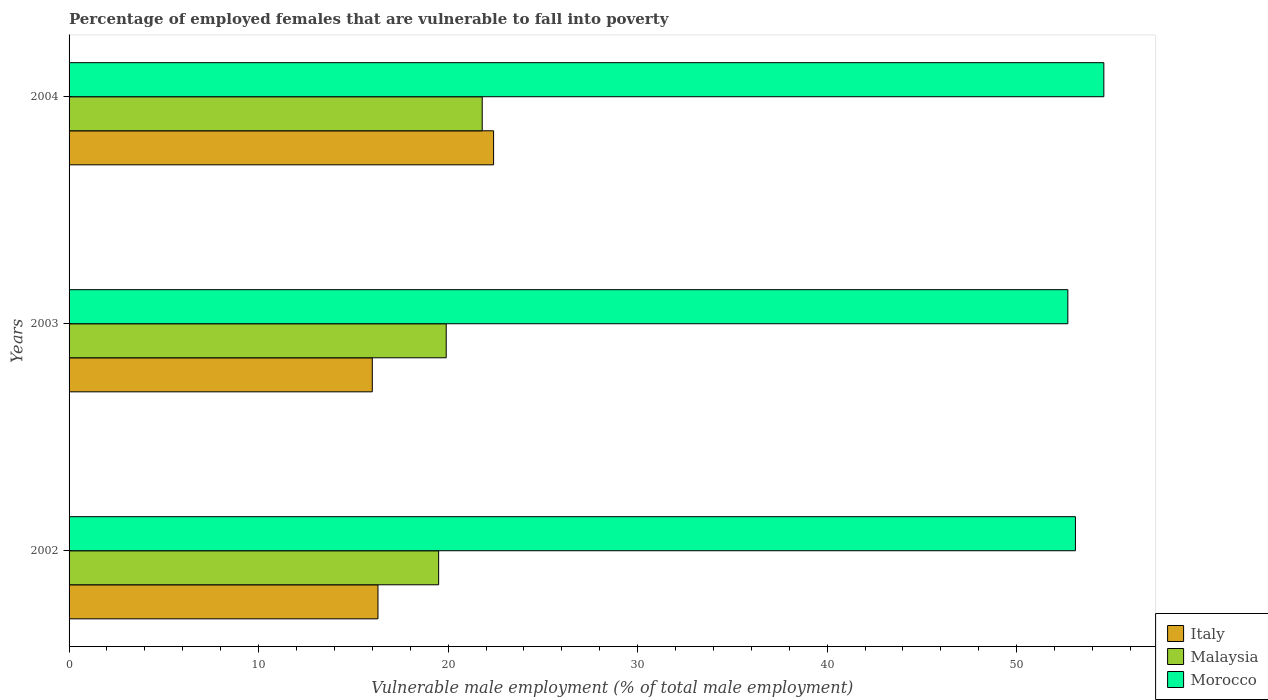How many different coloured bars are there?
Your answer should be compact. 3. How many groups of bars are there?
Give a very brief answer. 3. Are the number of bars on each tick of the Y-axis equal?
Make the answer very short. Yes. How many bars are there on the 1st tick from the bottom?
Your answer should be compact. 3. What is the label of the 1st group of bars from the top?
Your response must be concise. 2004. In how many cases, is the number of bars for a given year not equal to the number of legend labels?
Provide a short and direct response. 0. What is the percentage of employed females who are vulnerable to fall into poverty in Malaysia in 2002?
Keep it short and to the point. 19.5. Across all years, what is the maximum percentage of employed females who are vulnerable to fall into poverty in Morocco?
Your response must be concise. 54.6. Across all years, what is the minimum percentage of employed females who are vulnerable to fall into poverty in Morocco?
Provide a succinct answer. 52.7. In which year was the percentage of employed females who are vulnerable to fall into poverty in Malaysia maximum?
Provide a short and direct response. 2004. What is the total percentage of employed females who are vulnerable to fall into poverty in Italy in the graph?
Ensure brevity in your answer.  54.7. What is the difference between the percentage of employed females who are vulnerable to fall into poverty in Italy in 2002 and that in 2003?
Make the answer very short. 0.3. What is the difference between the percentage of employed females who are vulnerable to fall into poverty in Italy in 2004 and the percentage of employed females who are vulnerable to fall into poverty in Malaysia in 2003?
Your answer should be compact. 2.5. What is the average percentage of employed females who are vulnerable to fall into poverty in Italy per year?
Keep it short and to the point. 18.23. In the year 2004, what is the difference between the percentage of employed females who are vulnerable to fall into poverty in Morocco and percentage of employed females who are vulnerable to fall into poverty in Malaysia?
Provide a short and direct response. 32.8. What is the ratio of the percentage of employed females who are vulnerable to fall into poverty in Morocco in 2002 to that in 2003?
Offer a terse response. 1.01. What is the difference between the highest and the second highest percentage of employed females who are vulnerable to fall into poverty in Malaysia?
Provide a short and direct response. 1.9. What is the difference between the highest and the lowest percentage of employed females who are vulnerable to fall into poverty in Italy?
Keep it short and to the point. 6.4. Is the sum of the percentage of employed females who are vulnerable to fall into poverty in Malaysia in 2002 and 2003 greater than the maximum percentage of employed females who are vulnerable to fall into poverty in Morocco across all years?
Give a very brief answer. No. What does the 2nd bar from the bottom in 2004 represents?
Your answer should be very brief. Malaysia. Is it the case that in every year, the sum of the percentage of employed females who are vulnerable to fall into poverty in Morocco and percentage of employed females who are vulnerable to fall into poverty in Italy is greater than the percentage of employed females who are vulnerable to fall into poverty in Malaysia?
Make the answer very short. Yes. How many bars are there?
Offer a terse response. 9. Are all the bars in the graph horizontal?
Give a very brief answer. Yes. Are the values on the major ticks of X-axis written in scientific E-notation?
Provide a succinct answer. No. Does the graph contain any zero values?
Keep it short and to the point. No. How are the legend labels stacked?
Give a very brief answer. Vertical. What is the title of the graph?
Ensure brevity in your answer.  Percentage of employed females that are vulnerable to fall into poverty. Does "Nicaragua" appear as one of the legend labels in the graph?
Your response must be concise. No. What is the label or title of the X-axis?
Provide a succinct answer. Vulnerable male employment (% of total male employment). What is the label or title of the Y-axis?
Offer a terse response. Years. What is the Vulnerable male employment (% of total male employment) of Italy in 2002?
Your answer should be compact. 16.3. What is the Vulnerable male employment (% of total male employment) in Morocco in 2002?
Give a very brief answer. 53.1. What is the Vulnerable male employment (% of total male employment) in Italy in 2003?
Keep it short and to the point. 16. What is the Vulnerable male employment (% of total male employment) of Malaysia in 2003?
Your answer should be very brief. 19.9. What is the Vulnerable male employment (% of total male employment) in Morocco in 2003?
Offer a terse response. 52.7. What is the Vulnerable male employment (% of total male employment) of Italy in 2004?
Give a very brief answer. 22.4. What is the Vulnerable male employment (% of total male employment) of Malaysia in 2004?
Offer a terse response. 21.8. What is the Vulnerable male employment (% of total male employment) of Morocco in 2004?
Give a very brief answer. 54.6. Across all years, what is the maximum Vulnerable male employment (% of total male employment) in Italy?
Keep it short and to the point. 22.4. Across all years, what is the maximum Vulnerable male employment (% of total male employment) of Malaysia?
Your answer should be very brief. 21.8. Across all years, what is the maximum Vulnerable male employment (% of total male employment) in Morocco?
Offer a terse response. 54.6. Across all years, what is the minimum Vulnerable male employment (% of total male employment) in Italy?
Provide a short and direct response. 16. Across all years, what is the minimum Vulnerable male employment (% of total male employment) of Morocco?
Make the answer very short. 52.7. What is the total Vulnerable male employment (% of total male employment) in Italy in the graph?
Make the answer very short. 54.7. What is the total Vulnerable male employment (% of total male employment) of Malaysia in the graph?
Offer a very short reply. 61.2. What is the total Vulnerable male employment (% of total male employment) of Morocco in the graph?
Your response must be concise. 160.4. What is the difference between the Vulnerable male employment (% of total male employment) in Morocco in 2002 and that in 2003?
Make the answer very short. 0.4. What is the difference between the Vulnerable male employment (% of total male employment) in Italy in 2002 and that in 2004?
Offer a very short reply. -6.1. What is the difference between the Vulnerable male employment (% of total male employment) of Morocco in 2002 and that in 2004?
Offer a terse response. -1.5. What is the difference between the Vulnerable male employment (% of total male employment) of Morocco in 2003 and that in 2004?
Your answer should be compact. -1.9. What is the difference between the Vulnerable male employment (% of total male employment) of Italy in 2002 and the Vulnerable male employment (% of total male employment) of Malaysia in 2003?
Provide a succinct answer. -3.6. What is the difference between the Vulnerable male employment (% of total male employment) in Italy in 2002 and the Vulnerable male employment (% of total male employment) in Morocco in 2003?
Keep it short and to the point. -36.4. What is the difference between the Vulnerable male employment (% of total male employment) in Malaysia in 2002 and the Vulnerable male employment (% of total male employment) in Morocco in 2003?
Provide a succinct answer. -33.2. What is the difference between the Vulnerable male employment (% of total male employment) in Italy in 2002 and the Vulnerable male employment (% of total male employment) in Malaysia in 2004?
Offer a terse response. -5.5. What is the difference between the Vulnerable male employment (% of total male employment) of Italy in 2002 and the Vulnerable male employment (% of total male employment) of Morocco in 2004?
Provide a short and direct response. -38.3. What is the difference between the Vulnerable male employment (% of total male employment) in Malaysia in 2002 and the Vulnerable male employment (% of total male employment) in Morocco in 2004?
Provide a succinct answer. -35.1. What is the difference between the Vulnerable male employment (% of total male employment) in Italy in 2003 and the Vulnerable male employment (% of total male employment) in Malaysia in 2004?
Your response must be concise. -5.8. What is the difference between the Vulnerable male employment (% of total male employment) in Italy in 2003 and the Vulnerable male employment (% of total male employment) in Morocco in 2004?
Keep it short and to the point. -38.6. What is the difference between the Vulnerable male employment (% of total male employment) of Malaysia in 2003 and the Vulnerable male employment (% of total male employment) of Morocco in 2004?
Ensure brevity in your answer.  -34.7. What is the average Vulnerable male employment (% of total male employment) of Italy per year?
Make the answer very short. 18.23. What is the average Vulnerable male employment (% of total male employment) in Malaysia per year?
Your answer should be compact. 20.4. What is the average Vulnerable male employment (% of total male employment) in Morocco per year?
Your response must be concise. 53.47. In the year 2002, what is the difference between the Vulnerable male employment (% of total male employment) of Italy and Vulnerable male employment (% of total male employment) of Morocco?
Provide a succinct answer. -36.8. In the year 2002, what is the difference between the Vulnerable male employment (% of total male employment) of Malaysia and Vulnerable male employment (% of total male employment) of Morocco?
Give a very brief answer. -33.6. In the year 2003, what is the difference between the Vulnerable male employment (% of total male employment) of Italy and Vulnerable male employment (% of total male employment) of Morocco?
Provide a succinct answer. -36.7. In the year 2003, what is the difference between the Vulnerable male employment (% of total male employment) of Malaysia and Vulnerable male employment (% of total male employment) of Morocco?
Ensure brevity in your answer.  -32.8. In the year 2004, what is the difference between the Vulnerable male employment (% of total male employment) of Italy and Vulnerable male employment (% of total male employment) of Malaysia?
Your answer should be very brief. 0.6. In the year 2004, what is the difference between the Vulnerable male employment (% of total male employment) in Italy and Vulnerable male employment (% of total male employment) in Morocco?
Your response must be concise. -32.2. In the year 2004, what is the difference between the Vulnerable male employment (% of total male employment) of Malaysia and Vulnerable male employment (% of total male employment) of Morocco?
Keep it short and to the point. -32.8. What is the ratio of the Vulnerable male employment (% of total male employment) in Italy in 2002 to that in 2003?
Your answer should be very brief. 1.02. What is the ratio of the Vulnerable male employment (% of total male employment) of Malaysia in 2002 to that in 2003?
Offer a terse response. 0.98. What is the ratio of the Vulnerable male employment (% of total male employment) in Morocco in 2002 to that in 2003?
Offer a very short reply. 1.01. What is the ratio of the Vulnerable male employment (% of total male employment) in Italy in 2002 to that in 2004?
Ensure brevity in your answer.  0.73. What is the ratio of the Vulnerable male employment (% of total male employment) of Malaysia in 2002 to that in 2004?
Keep it short and to the point. 0.89. What is the ratio of the Vulnerable male employment (% of total male employment) in Morocco in 2002 to that in 2004?
Provide a succinct answer. 0.97. What is the ratio of the Vulnerable male employment (% of total male employment) of Malaysia in 2003 to that in 2004?
Ensure brevity in your answer.  0.91. What is the ratio of the Vulnerable male employment (% of total male employment) of Morocco in 2003 to that in 2004?
Offer a very short reply. 0.97. What is the difference between the highest and the second highest Vulnerable male employment (% of total male employment) in Italy?
Provide a short and direct response. 6.1. What is the difference between the highest and the second highest Vulnerable male employment (% of total male employment) of Malaysia?
Ensure brevity in your answer.  1.9. What is the difference between the highest and the lowest Vulnerable male employment (% of total male employment) in Italy?
Give a very brief answer. 6.4. 